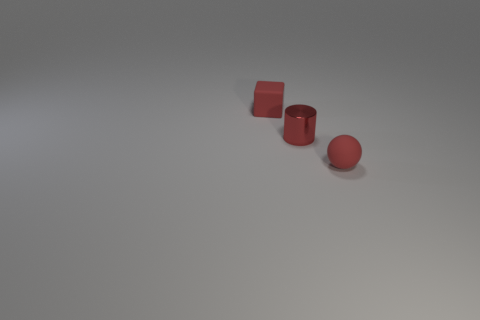How many other things are there of the same color as the tiny sphere?
Provide a succinct answer. 2. The red object that is made of the same material as the sphere is what shape?
Give a very brief answer. Cube. Is the number of small red rubber spheres in front of the small cube less than the number of rubber balls that are in front of the red sphere?
Your answer should be very brief. No. Are there more large purple metal cylinders than red objects?
Give a very brief answer. No. What material is the tiny block?
Make the answer very short. Rubber. There is a matte thing that is behind the metallic cylinder; what is its color?
Your answer should be very brief. Red. Is the number of shiny objects that are left of the tiny sphere greater than the number of small red things behind the metallic object?
Ensure brevity in your answer.  No. What size is the matte thing that is in front of the red rubber thing behind the tiny matte object that is on the right side of the tiny cylinder?
Offer a very short reply. Small. Are there any tiny objects of the same color as the small block?
Ensure brevity in your answer.  Yes. How many red rubber things are there?
Give a very brief answer. 2. 